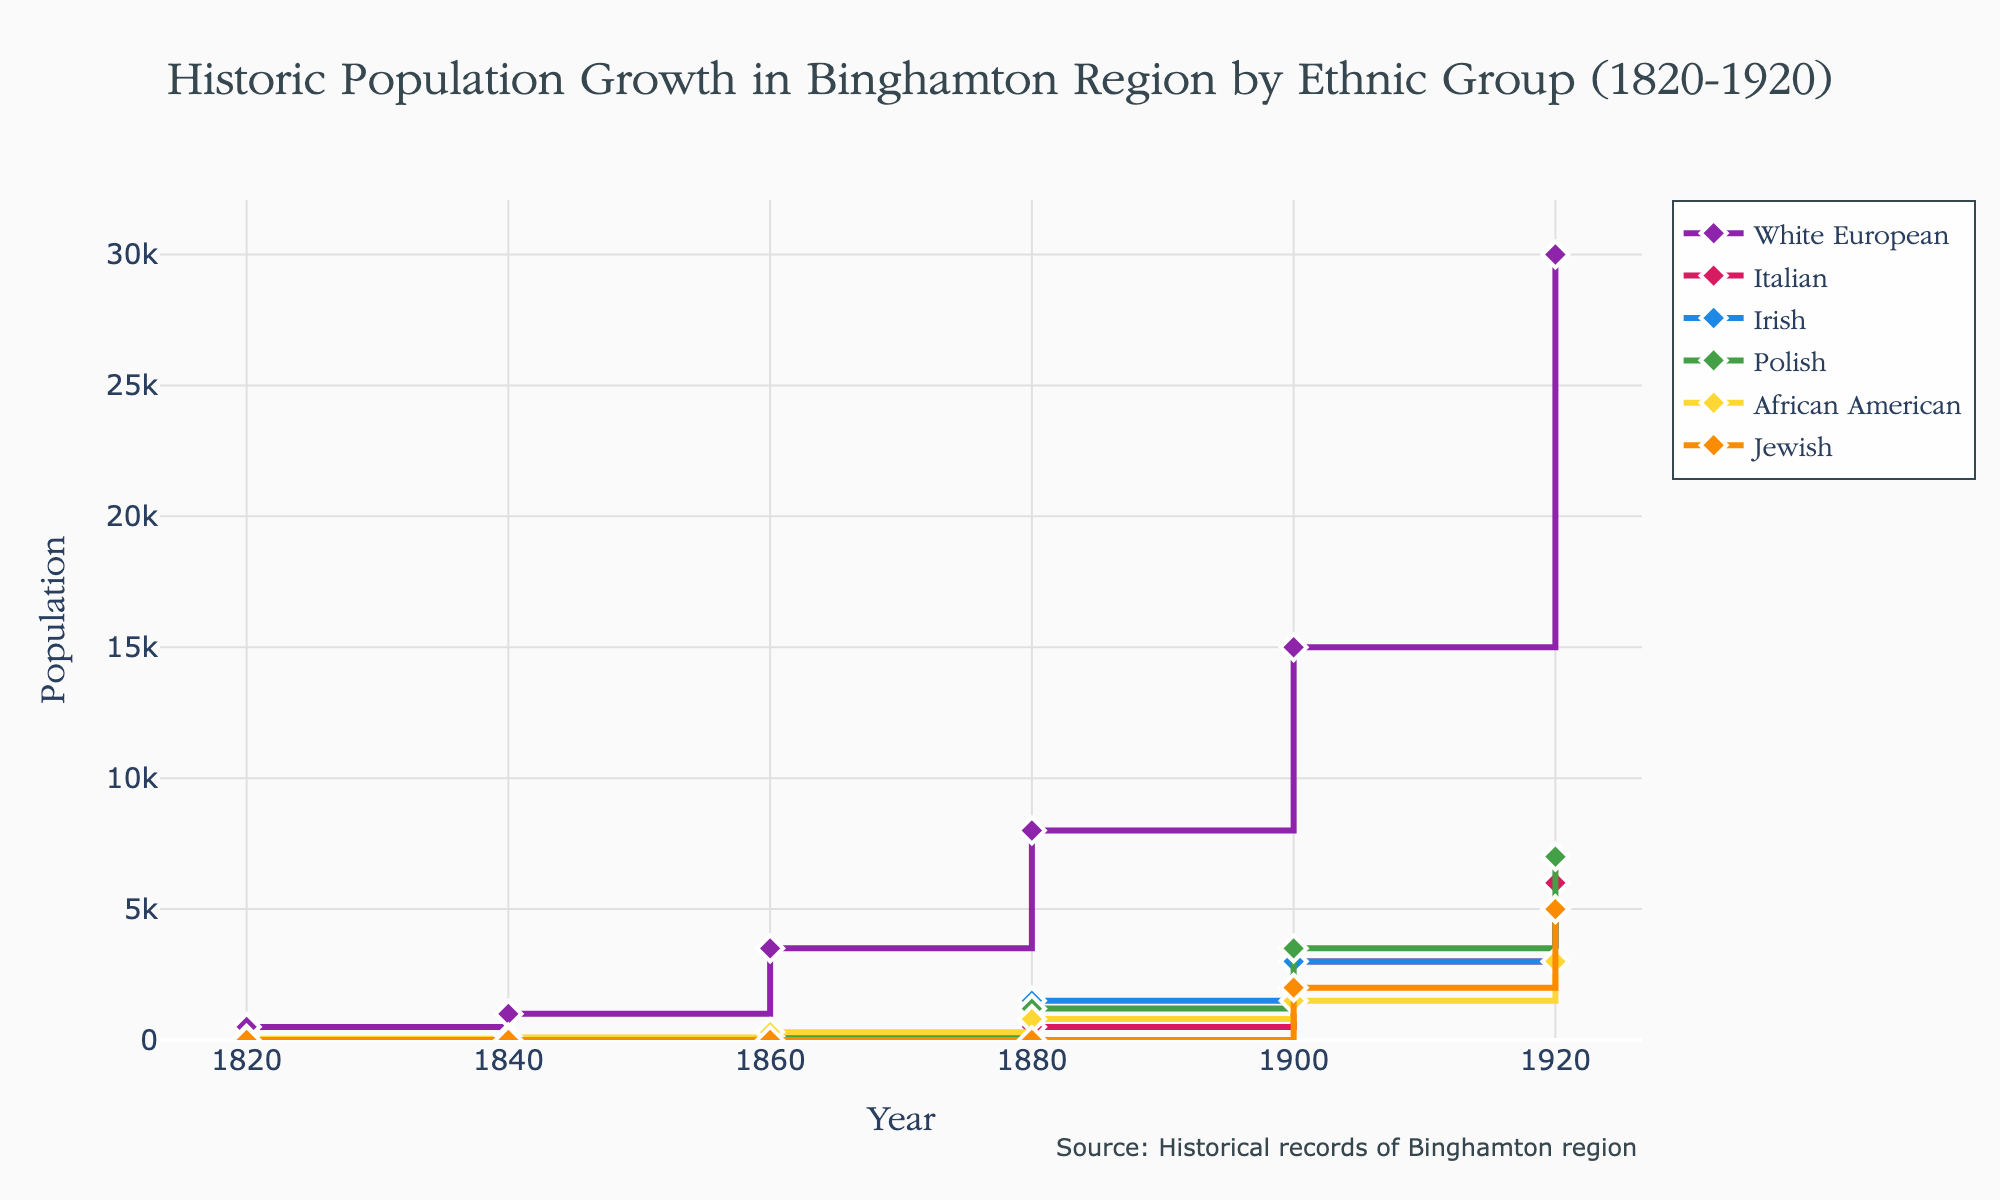What is the total population of the African American community in 1920? To find the total population of the African American community in 1920, look at the value on the y-axis corresponding to the African American group in 1920.
Answer: 3000 Which ethnic group had the highest population in 1860? Compare the population values of each ethnic group for the year 1860 to determine which is the highest. The White European population in 1860 is 3500, which is the highest among all groups for that year.
Answer: White European How many ethnic groups are represented in the figure? Count the number of different ethnic groups represented in the legend of the figure. There are six ethnic groups listed: White European, Italian, Irish, Polish, African American, and Jewish.
Answer: 6 What was the population growth of the Italian community from 1880 to 1920? Subtract the population of the Italian community in 1880 from its population in 1920. The Italian population in 1920 is 6000 and in 1880 it is 500. So, the growth is 6000 - 500.
Answer: 5500 In which decade did the Jewish community first appear in the population records? Identify the earliest year on the x-axis where a non-zero population value appears for the Jewish community. The Jewish community first appears in the records in 1900.
Answer: 1900 Compare the population growth of the Irish and Polish communities between 1900 and 1920. Which community grew more? Calculate the growth for both communities. Irish community growth: 5000 - 3000 = 2000. Polish community growth: 7000 - 3500 = 3500.
Answer: Polish How much larger was the White European population compared to the African American population in 1900? Subtract the African American population from the White European population for the year 1900. White European population: 15000, African American population: 1500. Difference: 15000 - 1500.
Answer: 13500 What is the overall trend in population for the White European group from 1820 to 1920? By looking at the line representing the White European group from 1820 to 1920, describe the overall population trend. The trend shows a steady increase over the years.
Answer: Steady increase What percentage of the total 1920 population did the Jewish community account for? Calculate the total population for all groups in 1920, and then find the percentage that the Jewish community represents. Total in 1920: 30000 (White European) + 6000 (Italian) + 5000 (Irish) + 7000 (Polish) + 3000 (African American) + 5000 (Jewish) = 56000. Jewish percentage: (5000 / 56000) * 100.
Answer: ~8.93% What is the population difference between the Italian and Irish communities in 1880? Subtract the Irish population from the Italian population for the year 1880. Italian population: 500, Irish population: 1500. Difference: 1500 - 500.
Answer: 1000 